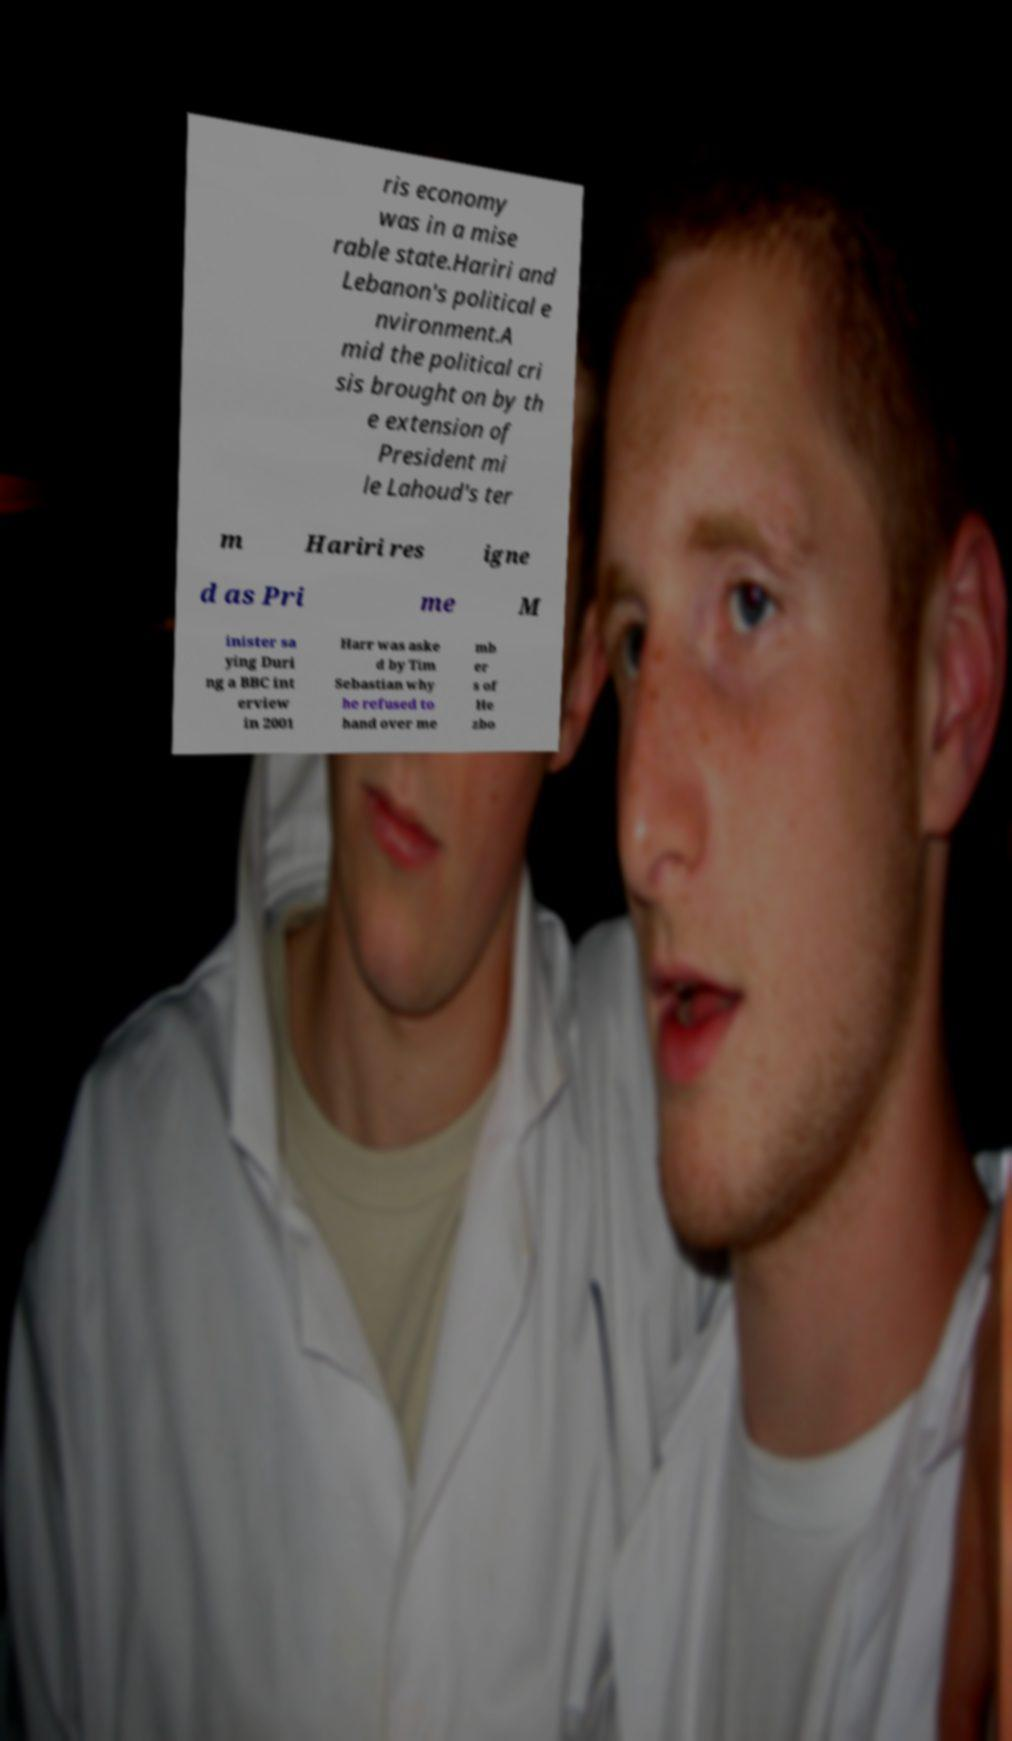What messages or text are displayed in this image? I need them in a readable, typed format. ris economy was in a mise rable state.Hariri and Lebanon's political e nvironment.A mid the political cri sis brought on by th e extension of President mi le Lahoud's ter m Hariri res igne d as Pri me M inister sa ying Duri ng a BBC int erview in 2001 Harr was aske d by Tim Sebastian why he refused to hand over me mb er s of He zbo 